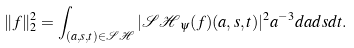Convert formula to latex. <formula><loc_0><loc_0><loc_500><loc_500>\| f \| _ { 2 } ^ { 2 } = \int _ { ( a , s , t ) \in \mathcal { S H } } | \mathcal { S H } _ { \psi } ( f ) ( a , s , t ) | ^ { 2 } a ^ { - 3 } d a d s d t .</formula> 